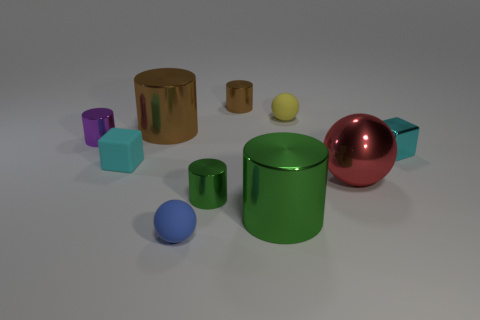Subtract all purple metallic cylinders. How many cylinders are left? 4 Subtract all purple cylinders. How many cylinders are left? 4 Subtract all gray cylinders. Subtract all cyan balls. How many cylinders are left? 5 Subtract all cubes. How many objects are left? 8 Add 2 metal blocks. How many metal blocks exist? 3 Subtract 0 green blocks. How many objects are left? 10 Subtract all red shiny balls. Subtract all brown objects. How many objects are left? 7 Add 2 green metal cylinders. How many green metal cylinders are left? 4 